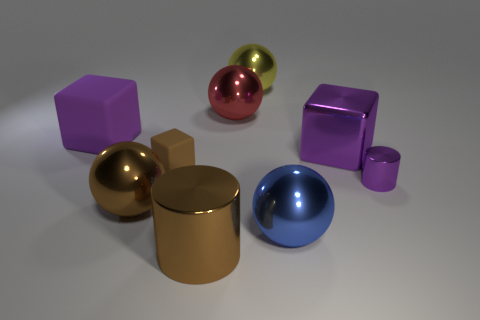There is a purple object behind the big purple shiny cube; is it the same size as the brown metallic object right of the tiny brown block?
Keep it short and to the point. Yes. There is another shiny thing that is the same shape as the tiny shiny thing; what is its color?
Make the answer very short. Brown. Is the shape of the yellow shiny thing the same as the large rubber object?
Offer a terse response. No. What size is the brown thing that is the same shape as the big yellow metal object?
Your answer should be compact. Large. What number of large blue objects have the same material as the small cube?
Keep it short and to the point. 0. How many things are large blue metallic spheres or big purple metal things?
Ensure brevity in your answer.  2. Are there any large metallic cylinders to the left of the object in front of the blue sphere?
Keep it short and to the point. No. Is the number of purple things on the right side of the purple shiny cube greater than the number of small purple objects that are behind the small shiny object?
Offer a very short reply. Yes. What is the material of the sphere that is the same color as the small rubber thing?
Keep it short and to the point. Metal. What number of small metallic cylinders have the same color as the big matte object?
Offer a terse response. 1. 